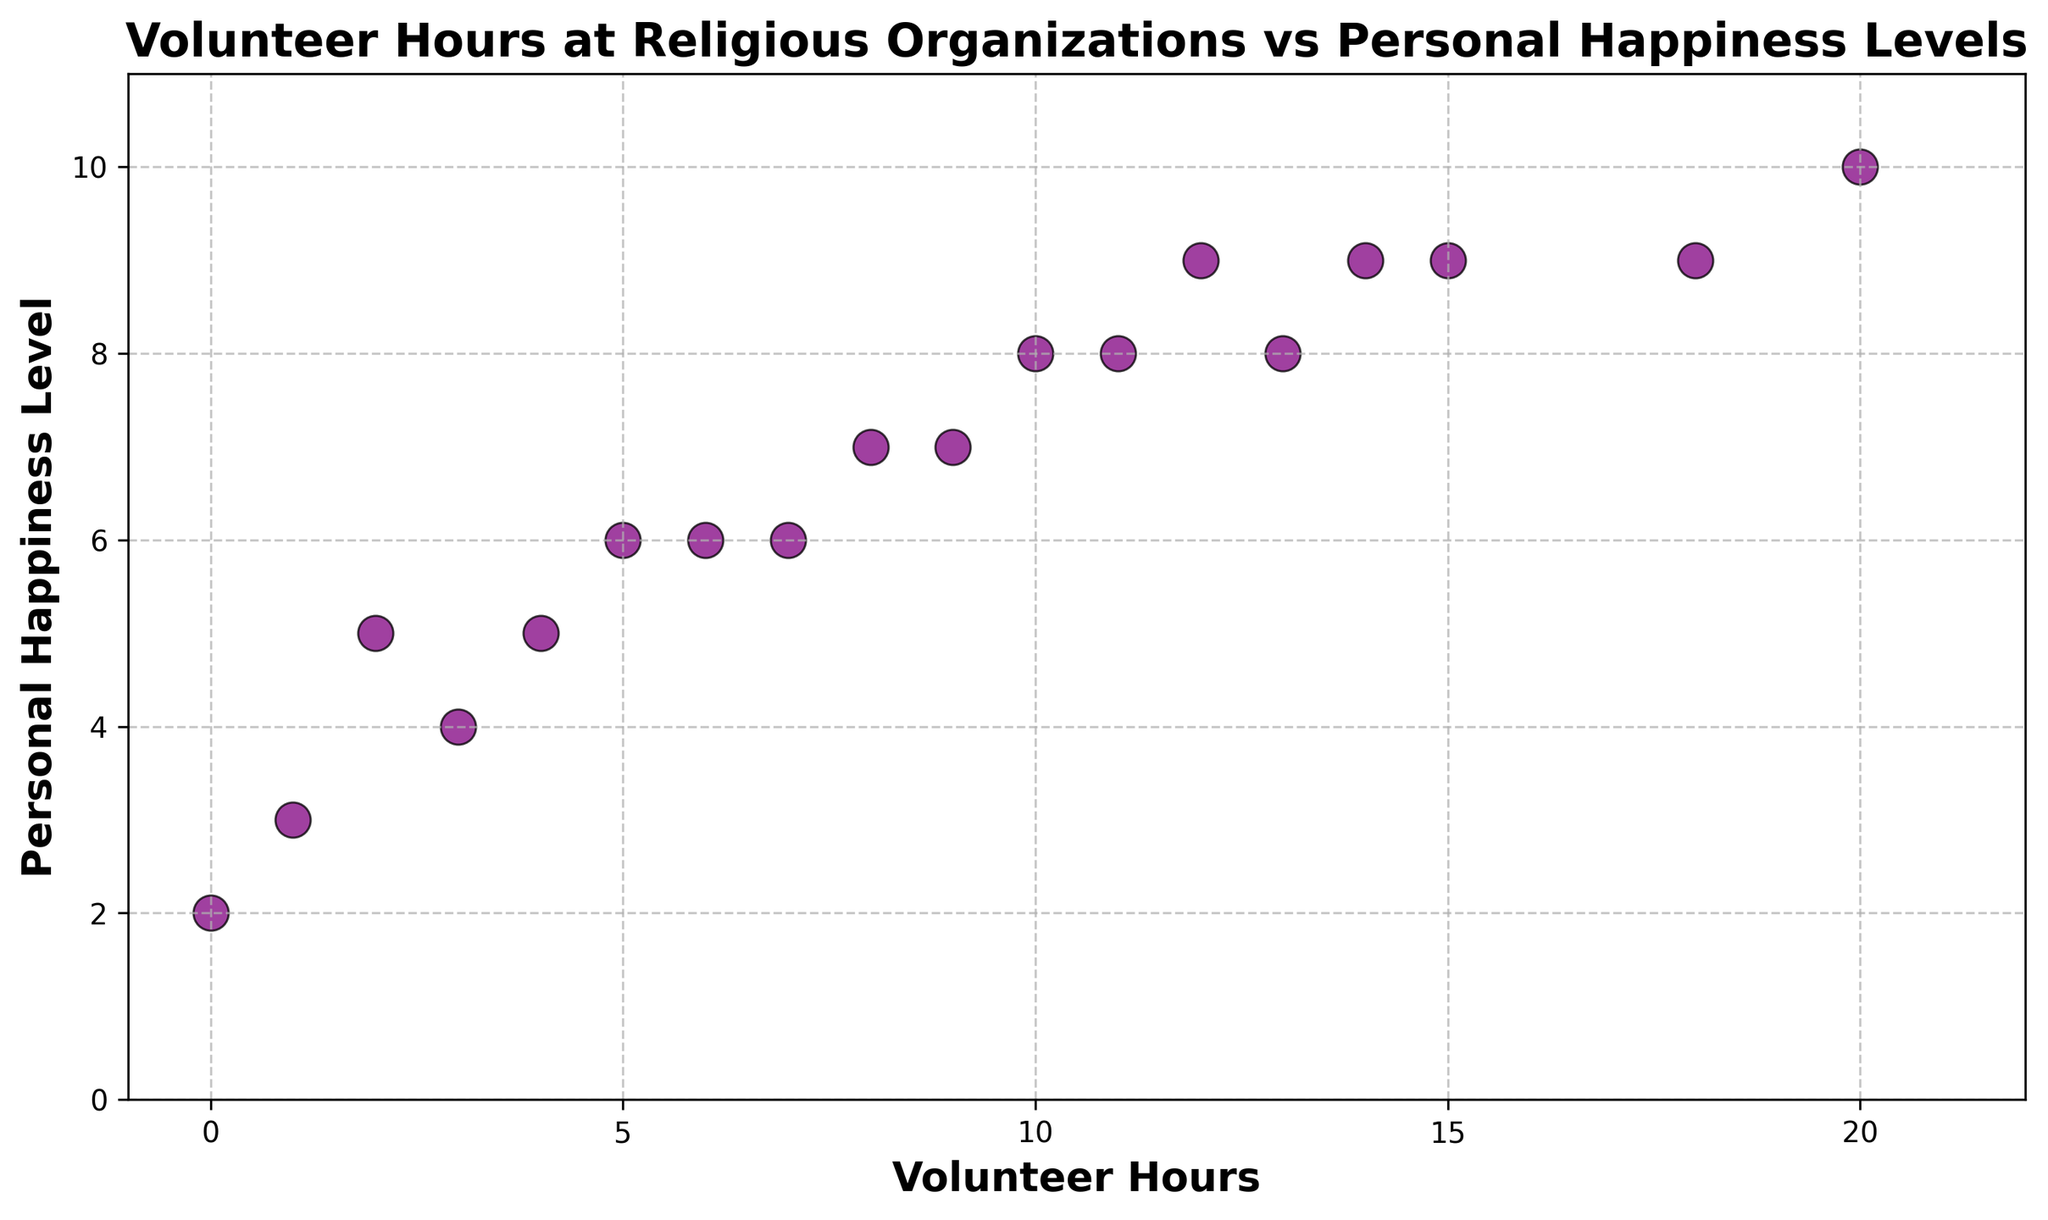What's the maximum number of volunteer hours recorded? The scatter plot shows individual data points with volunteer hours on the X-axis. By observing the plot, we can see the highest point on the X-axis represents the maximum volunteer hours.
Answer: 20 What is the relationship between volunteer hours and personal happiness levels? By examining the trend of the scatter plot, observe whether the points generally increase, decrease, or have no pattern. The scatter plot shows an upward trend, indicating that more volunteer hours generally correlate with higher happiness levels.
Answer: Positive correlation What is the difference in personal happiness levels for someone who volunteers 12 hours compared to someone who volunteers 3 hours? Locate the points for 12 and 3 volunteer hours on the X-axis and observe their corresponding happiness levels on the Y-axis. For 12 hours, the happiness level is 9, and for 3 hours, it is 4. The difference is 9 - 4.
Answer: 5 Which two closely related data points have the largest difference in personal happiness levels? By visually comparing the vertical distances between adjacent scatter points, identify pairs with noticeable differences.
Answer: 1 hour and 2 hours (3 and 5 levels respectively) What is the average personal happiness level for people who volunteer between 5 and 10 hours? Identify the points in this range and their corresponding happiness levels. The points are (5, 6), (8, 7), (6, 6), (7, 6), (10, 8). Calculate the average of 6, 7, 6, 6, 8. Sum = 33, Number of points = 5, Average = 33 / 5.
Answer: 6.6 What is the most common personal happiness level among those who volunteer hours? Observe the Y-axis values and note how frequently each level appears by counting the points aligned horizontal to each value.
Answer: 9 Which data point has the lowest personal happiness level? Find the points on the scatter plot that have the lowest position along the Y-axis. The data point at 0 volunteer hours has the lowest happiness level, equal to 2.
Answer: (0, 2) What is the range of personal happiness levels for people who volunteer between 10 and 15 hours? Identify the points within this range and their happiness levels. The points are (10, 8), (11, 8), (14, 9), (13, 8), (15, 9). The minimum is 8, and the maximum is 9. The range is 9 - 8.
Answer: 1 Are there any outliers in the scatter plot that do not follow the general trend of increasing happiness with more volunteer hours? Examine the points to identify any anomalies or points far from the general trend line.
Answer: No noticeable outliers What is the sum of personal happiness levels for individuals volunteering exactly 6 and 11 hours? Find the points for these hours and note their levels. For 6 hours, the level is 6. For 11 hours, the level is 8. Calculate 6 + 8.
Answer: 14 